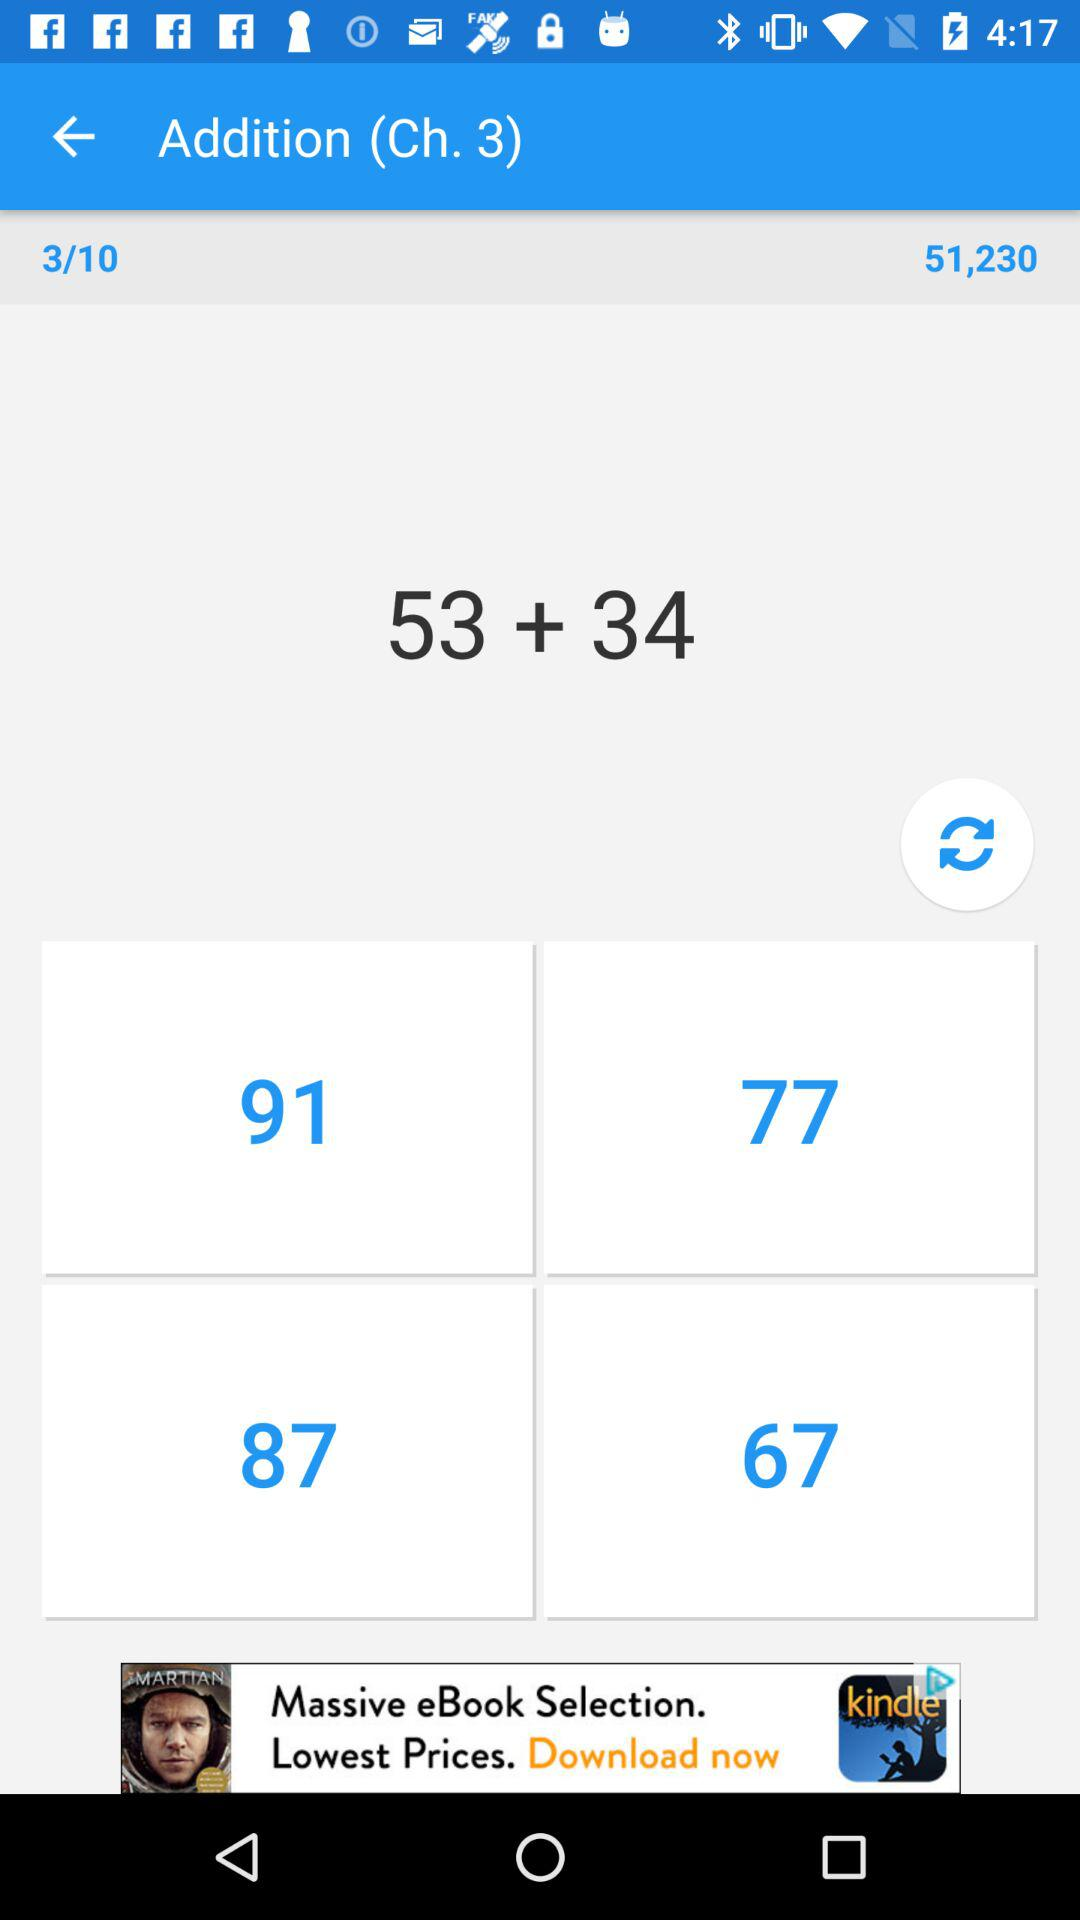Which chapter is shown? The shown chapter is "Addition". 